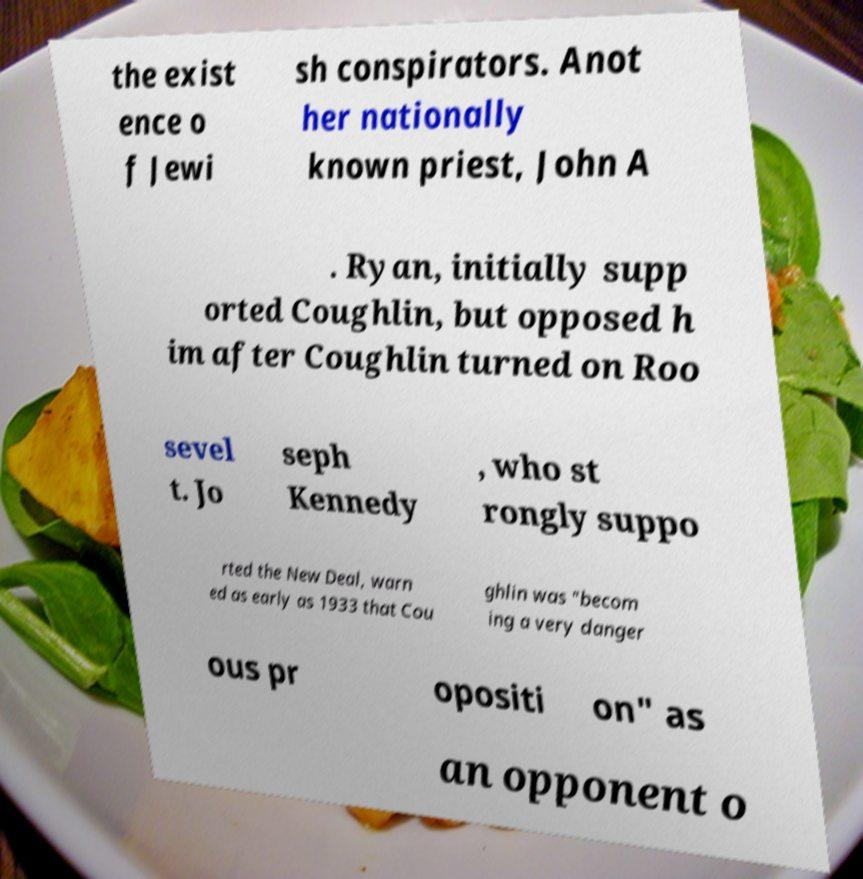I need the written content from this picture converted into text. Can you do that? the exist ence o f Jewi sh conspirators. Anot her nationally known priest, John A . Ryan, initially supp orted Coughlin, but opposed h im after Coughlin turned on Roo sevel t. Jo seph Kennedy , who st rongly suppo rted the New Deal, warn ed as early as 1933 that Cou ghlin was "becom ing a very danger ous pr opositi on" as an opponent o 